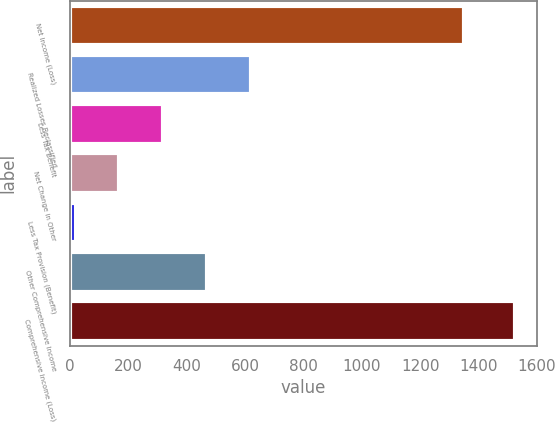Convert chart to OTSL. <chart><loc_0><loc_0><loc_500><loc_500><bar_chart><fcel>Net Income (Loss)<fcel>Realized Losses Reclassified<fcel>Less Tax Benefit<fcel>Net Change in Other<fcel>Less Tax Provision (Benefit)<fcel>Other Comprehensive Income<fcel>Comprehensive Income (Loss)<nl><fcel>1350<fcel>621<fcel>320<fcel>169.5<fcel>19<fcel>470.5<fcel>1524<nl></chart> 